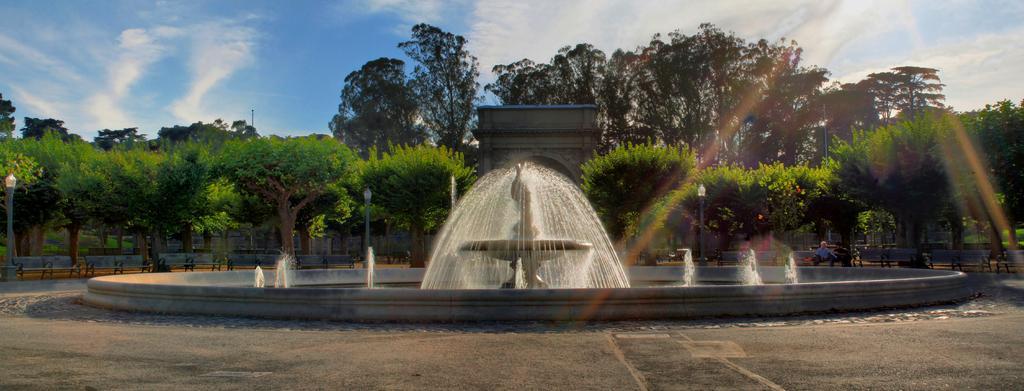How would you summarize this image in a sentence or two? In the image there is water fall in the middle with trees behind it all over the place and above its sky with clouds. 